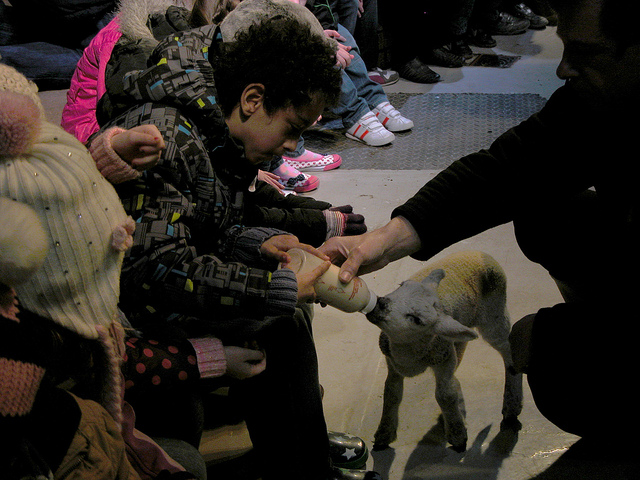<image>Why is he feeding the goat? It is not certain why he is feeding the goat. It could be because the goat is hungry or for fun. Why is he feeding the goat? He is feeding the goat because it is hungry. 